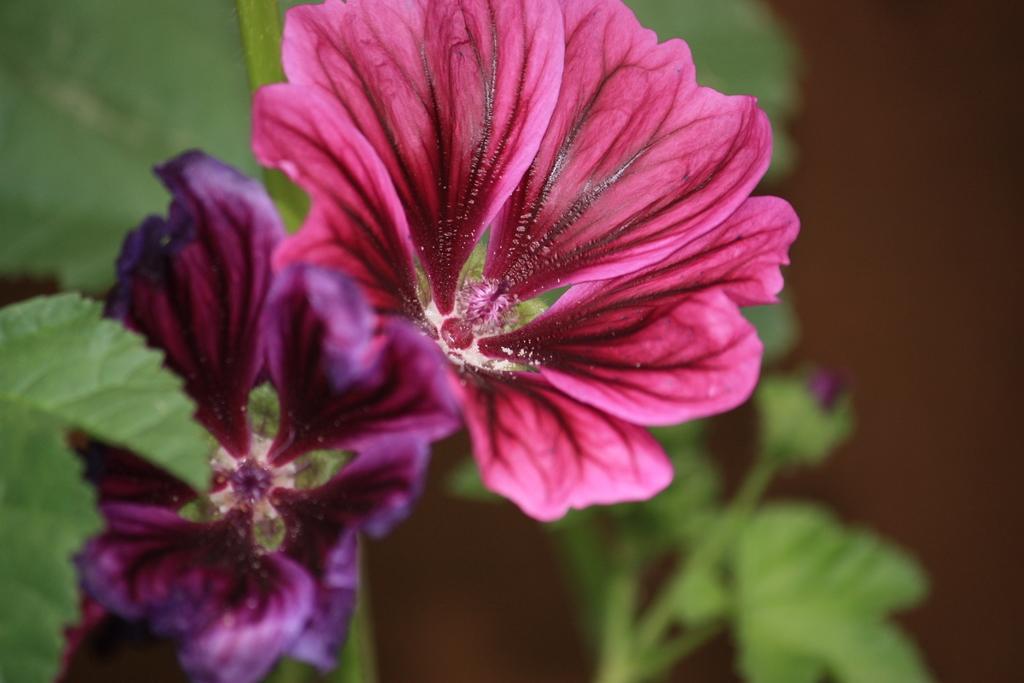In one or two sentences, can you explain what this image depicts? In this picture we can see flowers and leaves. In the background of the image it is blurry. 